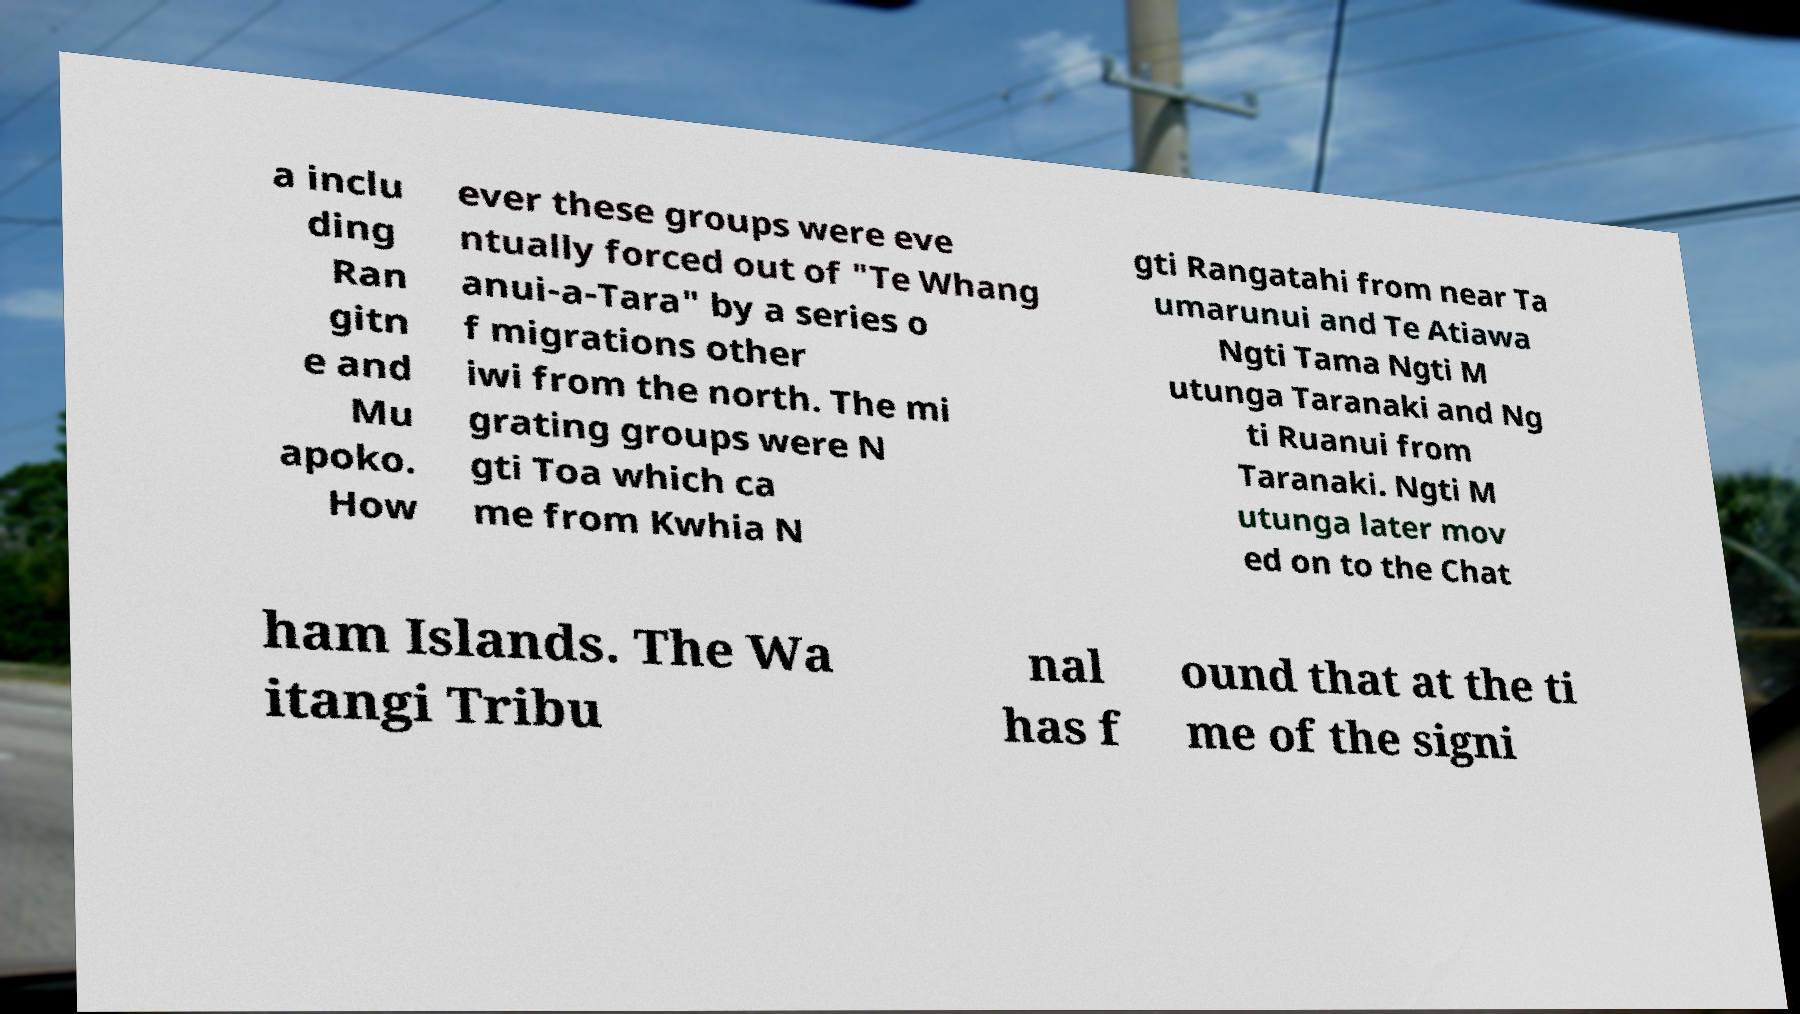There's text embedded in this image that I need extracted. Can you transcribe it verbatim? a inclu ding Ran gitn e and Mu apoko. How ever these groups were eve ntually forced out of "Te Whang anui-a-Tara" by a series o f migrations other iwi from the north. The mi grating groups were N gti Toa which ca me from Kwhia N gti Rangatahi from near Ta umarunui and Te Atiawa Ngti Tama Ngti M utunga Taranaki and Ng ti Ruanui from Taranaki. Ngti M utunga later mov ed on to the Chat ham Islands. The Wa itangi Tribu nal has f ound that at the ti me of the signi 